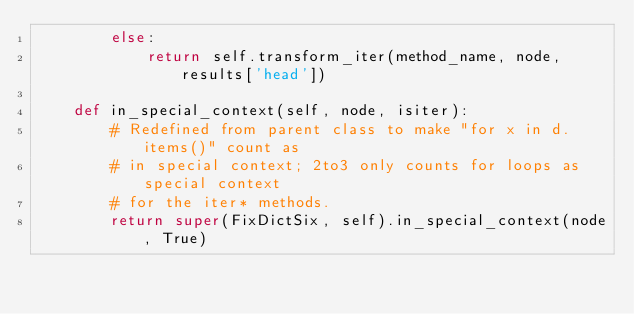<code> <loc_0><loc_0><loc_500><loc_500><_Python_>        else:
            return self.transform_iter(method_name, node, results['head'])

    def in_special_context(self, node, isiter):
        # Redefined from parent class to make "for x in d.items()" count as
        # in special context; 2to3 only counts for loops as special context
        # for the iter* methods.
        return super(FixDictSix, self).in_special_context(node, True)
</code> 